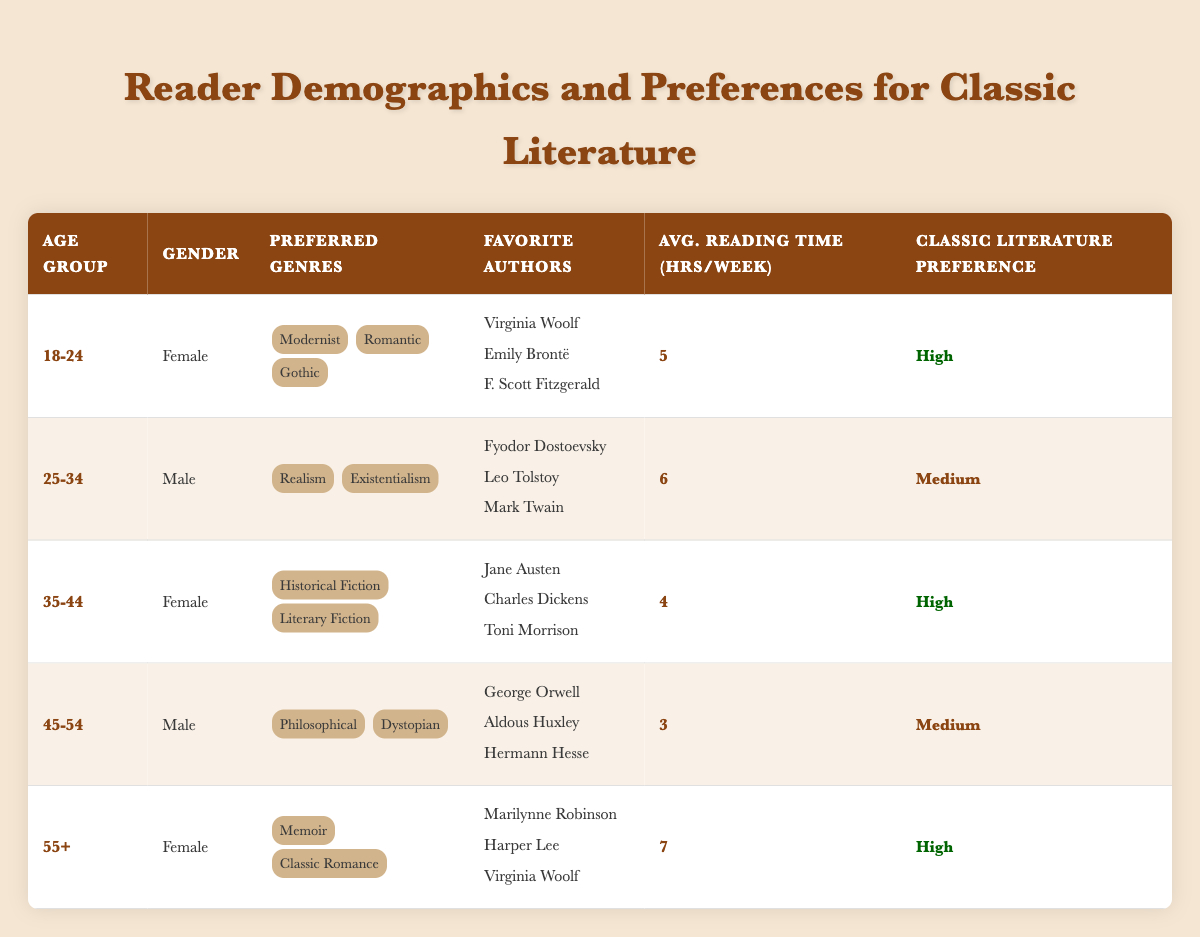What is the classic literature preference of the 18-24 age group? In the table, the classic literature preference for the 18-24 age group is indicated as "High."
Answer: High How many authors are favored by readers in the 35-44 age group? The 35-44 age group lists three favorite authors: Jane Austen, Charles Dickens, and Toni Morrison.
Answer: 3 What average reading time per week do 55+ year-old females spend on reading? The table shows that the average reading time for 55+ year-old females is 7 hours per week.
Answer: 7 Which gender has a medium preference for classic literature? Both the 25-34 and 45-54 age groups, which are male, have a medium preference for classic literature.
Answer: Male What is the highest average reading time per week among all groups? The highest average reading time per week is 7 hours for the 55+ age group.
Answer: 7 Are there more males or females in the 45-54 age group? There is only one male in the 45-54 age group, making it a true statement that there are more females in this specific group (no females listed).
Answer: False What percentage of the demographic groups with a high preference for classic literature includes females? Three out of five demographic groups have a high preference, and all of them (three groups) are female. Therefore, the percentage is (3/5) * 100 = 60%.
Answer: 60% How does the average reading time for the 25-34 age group compare to the 35-44 age group? The average reading time for the 25-34 age group is 6 hours, while the 35-44 age group's average is 4 hours. Consequently, the 25-34 age group reads 2 hours more on average.
Answer: 2 hours Which group has the most varied preferred genres? The 18-24 age group lists three preferred genres: Modernist, Romantic, and Gothic. Other groups have either two or only one genre listed.
Answer: 18-24 age group Is there a trend in classic literature preference matching the average reading time among the age groups? The data shows that groups with high classic literature preference (18-24, 35-44, 55+) have higher weekly reading times, while the medium preference groups (25-34, 45-54) have lower reading times. This suggests a correlation.
Answer: Yes 